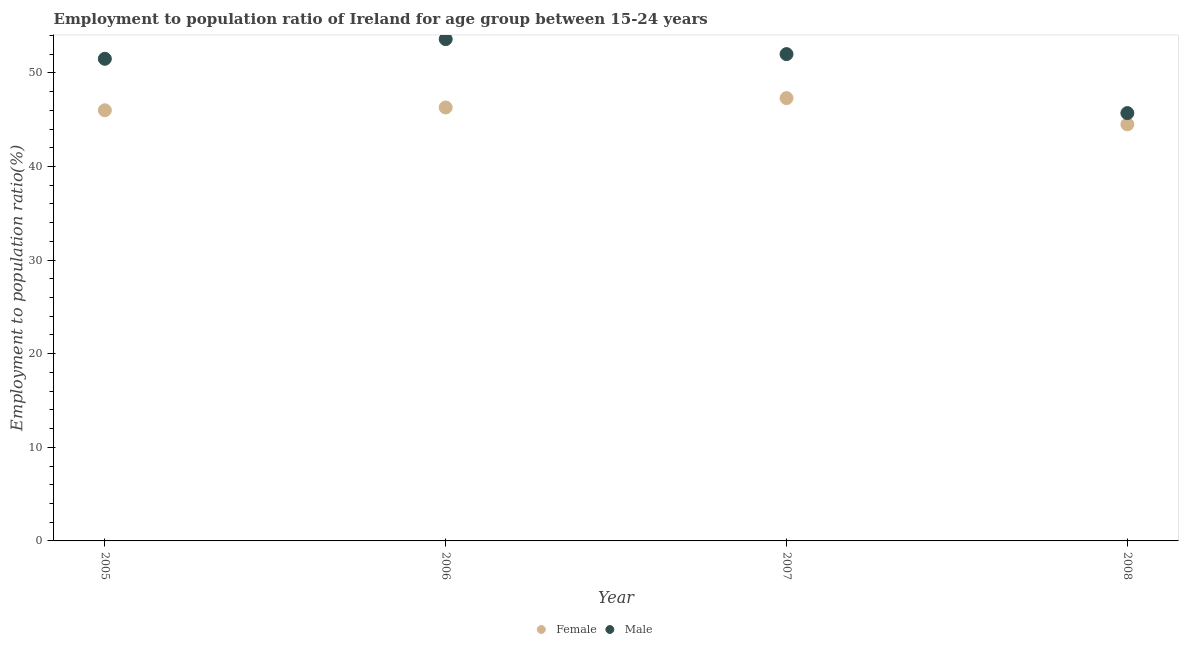How many different coloured dotlines are there?
Your response must be concise. 2. What is the employment to population ratio(female) in 2008?
Offer a terse response. 44.5. Across all years, what is the maximum employment to population ratio(female)?
Your response must be concise. 47.3. Across all years, what is the minimum employment to population ratio(female)?
Your response must be concise. 44.5. In which year was the employment to population ratio(male) minimum?
Offer a very short reply. 2008. What is the total employment to population ratio(male) in the graph?
Provide a succinct answer. 202.8. What is the difference between the employment to population ratio(male) in 2007 and that in 2008?
Provide a succinct answer. 6.3. What is the difference between the employment to population ratio(female) in 2007 and the employment to population ratio(male) in 2005?
Keep it short and to the point. -4.2. What is the average employment to population ratio(female) per year?
Provide a succinct answer. 46.02. In the year 2007, what is the difference between the employment to population ratio(female) and employment to population ratio(male)?
Offer a very short reply. -4.7. In how many years, is the employment to population ratio(male) greater than 44 %?
Provide a succinct answer. 4. What is the ratio of the employment to population ratio(male) in 2006 to that in 2007?
Provide a succinct answer. 1.03. Is the employment to population ratio(male) in 2007 less than that in 2008?
Your answer should be compact. No. Is the difference between the employment to population ratio(male) in 2006 and 2008 greater than the difference between the employment to population ratio(female) in 2006 and 2008?
Keep it short and to the point. Yes. What is the difference between the highest and the second highest employment to population ratio(male)?
Give a very brief answer. 1.6. What is the difference between the highest and the lowest employment to population ratio(male)?
Your answer should be very brief. 7.9. In how many years, is the employment to population ratio(female) greater than the average employment to population ratio(female) taken over all years?
Provide a succinct answer. 2. Is the employment to population ratio(female) strictly greater than the employment to population ratio(male) over the years?
Your answer should be compact. No. How many dotlines are there?
Your answer should be compact. 2. How many years are there in the graph?
Ensure brevity in your answer.  4. Does the graph contain any zero values?
Provide a short and direct response. No. Where does the legend appear in the graph?
Give a very brief answer. Bottom center. How many legend labels are there?
Offer a terse response. 2. How are the legend labels stacked?
Give a very brief answer. Horizontal. What is the title of the graph?
Provide a short and direct response. Employment to population ratio of Ireland for age group between 15-24 years. What is the label or title of the X-axis?
Your answer should be compact. Year. What is the label or title of the Y-axis?
Your answer should be compact. Employment to population ratio(%). What is the Employment to population ratio(%) of Female in 2005?
Your response must be concise. 46. What is the Employment to population ratio(%) in Male in 2005?
Offer a terse response. 51.5. What is the Employment to population ratio(%) in Female in 2006?
Give a very brief answer. 46.3. What is the Employment to population ratio(%) of Male in 2006?
Offer a terse response. 53.6. What is the Employment to population ratio(%) of Female in 2007?
Give a very brief answer. 47.3. What is the Employment to population ratio(%) of Female in 2008?
Your answer should be compact. 44.5. What is the Employment to population ratio(%) in Male in 2008?
Provide a short and direct response. 45.7. Across all years, what is the maximum Employment to population ratio(%) of Female?
Offer a terse response. 47.3. Across all years, what is the maximum Employment to population ratio(%) in Male?
Provide a succinct answer. 53.6. Across all years, what is the minimum Employment to population ratio(%) in Female?
Give a very brief answer. 44.5. Across all years, what is the minimum Employment to population ratio(%) in Male?
Your response must be concise. 45.7. What is the total Employment to population ratio(%) of Female in the graph?
Keep it short and to the point. 184.1. What is the total Employment to population ratio(%) in Male in the graph?
Ensure brevity in your answer.  202.8. What is the difference between the Employment to population ratio(%) of Female in 2005 and that in 2006?
Ensure brevity in your answer.  -0.3. What is the difference between the Employment to population ratio(%) in Male in 2005 and that in 2008?
Offer a terse response. 5.8. What is the difference between the Employment to population ratio(%) in Female in 2006 and that in 2007?
Your answer should be very brief. -1. What is the difference between the Employment to population ratio(%) of Female in 2005 and the Employment to population ratio(%) of Male in 2006?
Offer a very short reply. -7.6. What is the difference between the Employment to population ratio(%) of Female in 2005 and the Employment to population ratio(%) of Male in 2007?
Make the answer very short. -6. What is the difference between the Employment to population ratio(%) of Female in 2005 and the Employment to population ratio(%) of Male in 2008?
Provide a short and direct response. 0.3. What is the difference between the Employment to population ratio(%) of Female in 2006 and the Employment to population ratio(%) of Male in 2007?
Keep it short and to the point. -5.7. What is the average Employment to population ratio(%) in Female per year?
Offer a very short reply. 46.02. What is the average Employment to population ratio(%) in Male per year?
Keep it short and to the point. 50.7. In the year 2005, what is the difference between the Employment to population ratio(%) of Female and Employment to population ratio(%) of Male?
Your response must be concise. -5.5. In the year 2006, what is the difference between the Employment to population ratio(%) of Female and Employment to population ratio(%) of Male?
Offer a very short reply. -7.3. In the year 2008, what is the difference between the Employment to population ratio(%) in Female and Employment to population ratio(%) in Male?
Ensure brevity in your answer.  -1.2. What is the ratio of the Employment to population ratio(%) of Female in 2005 to that in 2006?
Provide a short and direct response. 0.99. What is the ratio of the Employment to population ratio(%) of Male in 2005 to that in 2006?
Offer a terse response. 0.96. What is the ratio of the Employment to population ratio(%) of Female in 2005 to that in 2007?
Keep it short and to the point. 0.97. What is the ratio of the Employment to population ratio(%) in Female in 2005 to that in 2008?
Provide a succinct answer. 1.03. What is the ratio of the Employment to population ratio(%) in Male in 2005 to that in 2008?
Your response must be concise. 1.13. What is the ratio of the Employment to population ratio(%) of Female in 2006 to that in 2007?
Offer a terse response. 0.98. What is the ratio of the Employment to population ratio(%) of Male in 2006 to that in 2007?
Offer a terse response. 1.03. What is the ratio of the Employment to population ratio(%) in Female in 2006 to that in 2008?
Make the answer very short. 1.04. What is the ratio of the Employment to population ratio(%) of Male in 2006 to that in 2008?
Keep it short and to the point. 1.17. What is the ratio of the Employment to population ratio(%) in Female in 2007 to that in 2008?
Make the answer very short. 1.06. What is the ratio of the Employment to population ratio(%) in Male in 2007 to that in 2008?
Your answer should be compact. 1.14. What is the difference between the highest and the second highest Employment to population ratio(%) of Female?
Give a very brief answer. 1. What is the difference between the highest and the lowest Employment to population ratio(%) in Female?
Your answer should be very brief. 2.8. What is the difference between the highest and the lowest Employment to population ratio(%) of Male?
Offer a terse response. 7.9. 